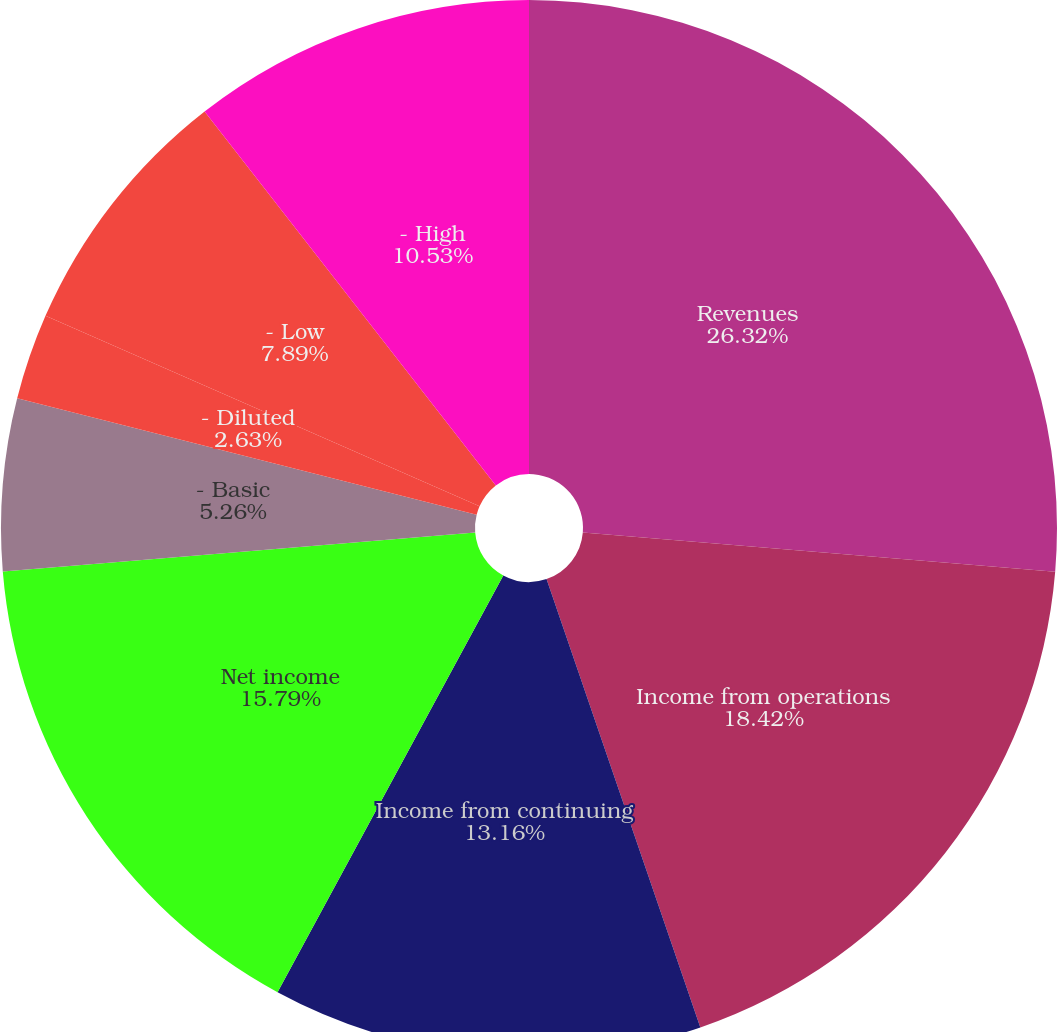Convert chart. <chart><loc_0><loc_0><loc_500><loc_500><pie_chart><fcel>Revenues<fcel>Income from operations<fcel>Income from continuing<fcel>Net income<fcel>- Basic<fcel>- Diluted<fcel>Dividends paid per share<fcel>- Low<fcel>- High<nl><fcel>26.32%<fcel>18.42%<fcel>13.16%<fcel>15.79%<fcel>5.26%<fcel>2.63%<fcel>0.0%<fcel>7.89%<fcel>10.53%<nl></chart> 